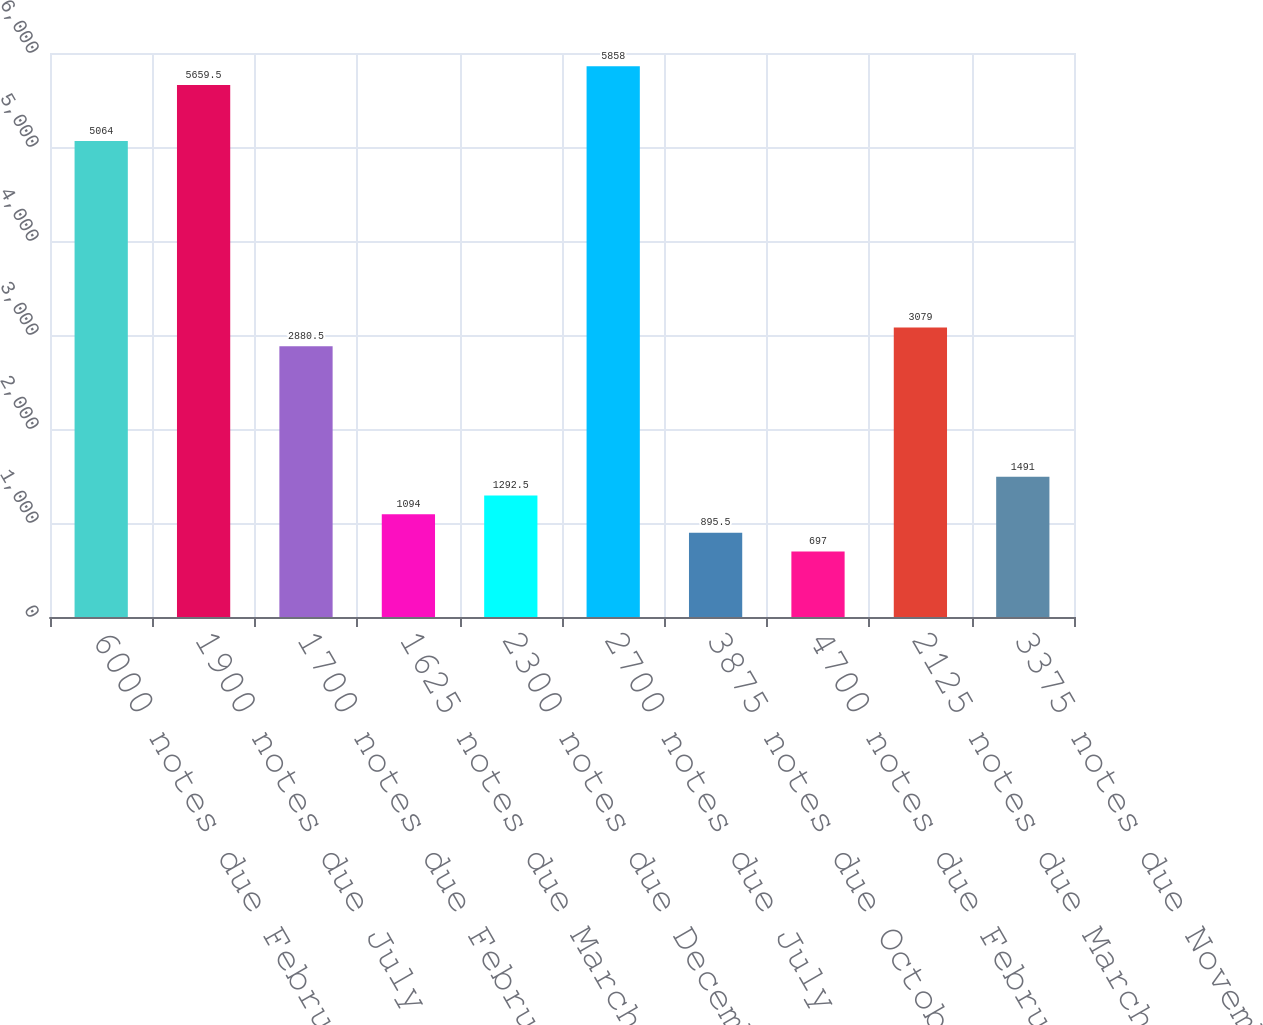Convert chart. <chart><loc_0><loc_0><loc_500><loc_500><bar_chart><fcel>6000 notes due February 2018<fcel>1900 notes due July 2018<fcel>1700 notes due February 2019<fcel>1625 notes due March 2019<fcel>2300 notes due December 2019<fcel>2700 notes due July 2020<fcel>3875 notes due October 2020<fcel>4700 notes due February 2021<fcel>2125 notes due March 2021<fcel>3375 notes due November 2021<nl><fcel>5064<fcel>5659.5<fcel>2880.5<fcel>1094<fcel>1292.5<fcel>5858<fcel>895.5<fcel>697<fcel>3079<fcel>1491<nl></chart> 